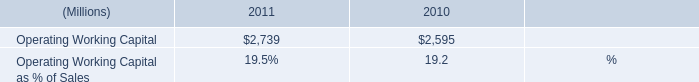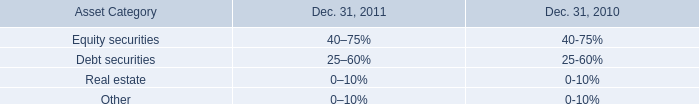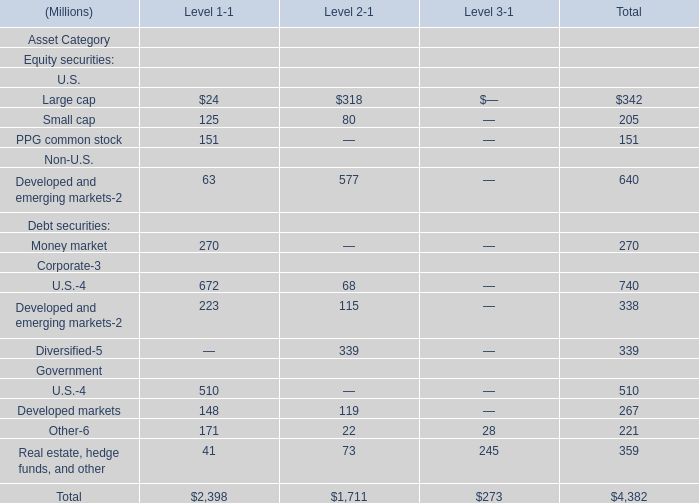What is the total value of Large capSmall capPPG common stock andDeveloped and emerging markets in total ? (in million) 
Computations: (((342 + 205) + 151) + 640)
Answer: 1338.0. 